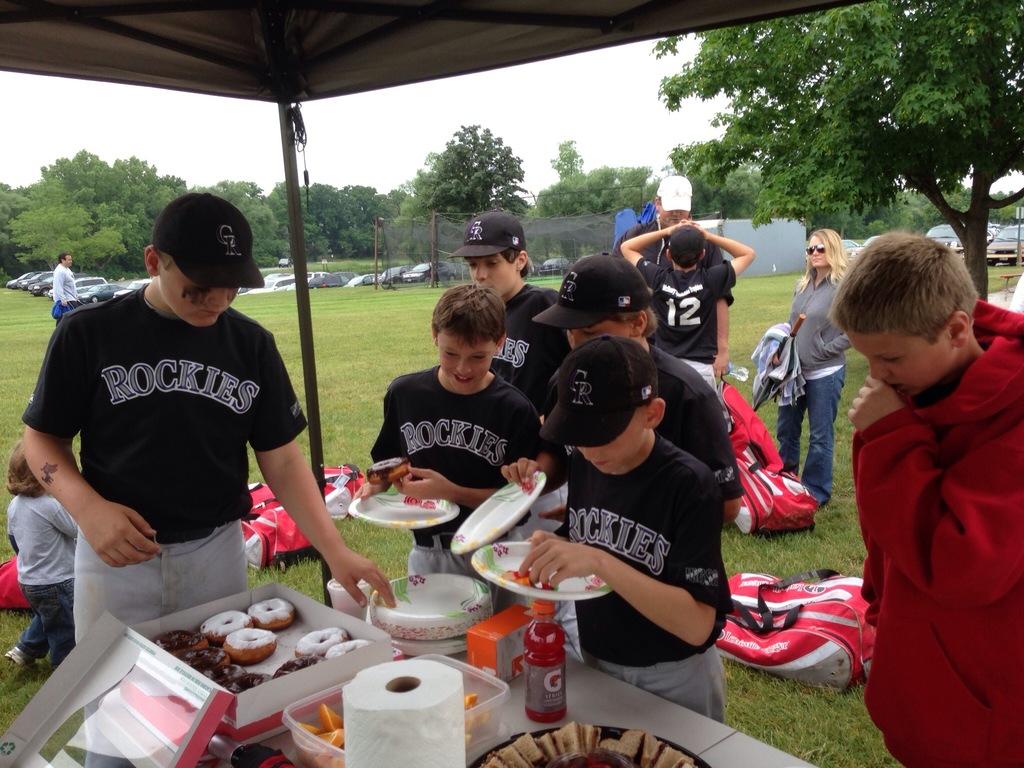What team is about to eat donuts?
Your answer should be compact. Rockies. What is the number of the player in the background?
Provide a succinct answer. 12. 